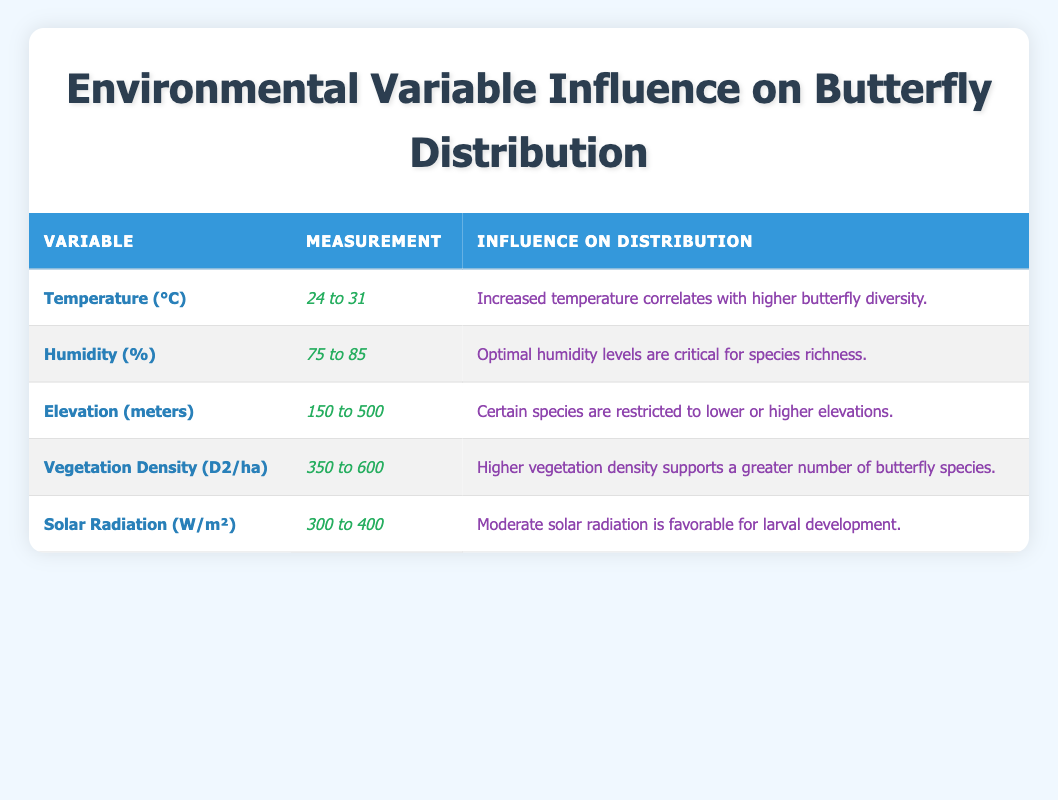What is the measurement range for humidity? The table states that the measurement for humidity ranges from 75 to 85. This is directly taken from the column labeled "Measurement" under the variable "Humidity (%)".
Answer: 75 to 85 Which environmental variable has the highest measurement value? By comparing the maximum values from each measurement: Temperature (31), Humidity (85), Elevation (500), Vegetation Density (600), and Solar Radiation (400), the highest is 600 for Vegetation Density.
Answer: Vegetation Density (600) Is the statement "Higher temperature decreases butterfly diversity" true based on the table? The table indicates that the influence of increased temperature is positively correlated with higher butterfly diversity, therefore making the statement false.
Answer: No What is the average measurement for solar radiation? The measurements for solar radiation are 300, 350, 400, 380, and 360. Summing these values gives 1790, and dividing by 5 (the number of measurements) results in an average of 358.
Answer: 358 For which environmental variable does the influence state that "Certain species are restricted"? Referring to the "Influence on Distribution" column, the statement about restrictions applies to the variable "Elevation (meters)", which specifies that certain species are restricted to lower or higher elevations.
Answer: Elevation (meters) What is the difference in the maximum and minimum measurements for vegetation density? The maximum measurement for vegetation density is 600 and the minimum is 350. To find the difference, subtract 350 from 600, resulting in a difference of 250.
Answer: 250 Does moderate solar radiation support larval development according to the lab results? The table clearly suggests that moderate solar radiation is favorable for larval development, confirming the statement as true.
Answer: Yes What is the combined range of temperature and humidity measurements? The temperature ranges from 24 to 31, and the humidity ranges from 75 to 85. To combine, one would state the ranges sequentially as follows: Temperature (24 to 31) and Humidity (75 to 85).
Answer: Temperature (24 to 31), Humidity (75 to 85) 